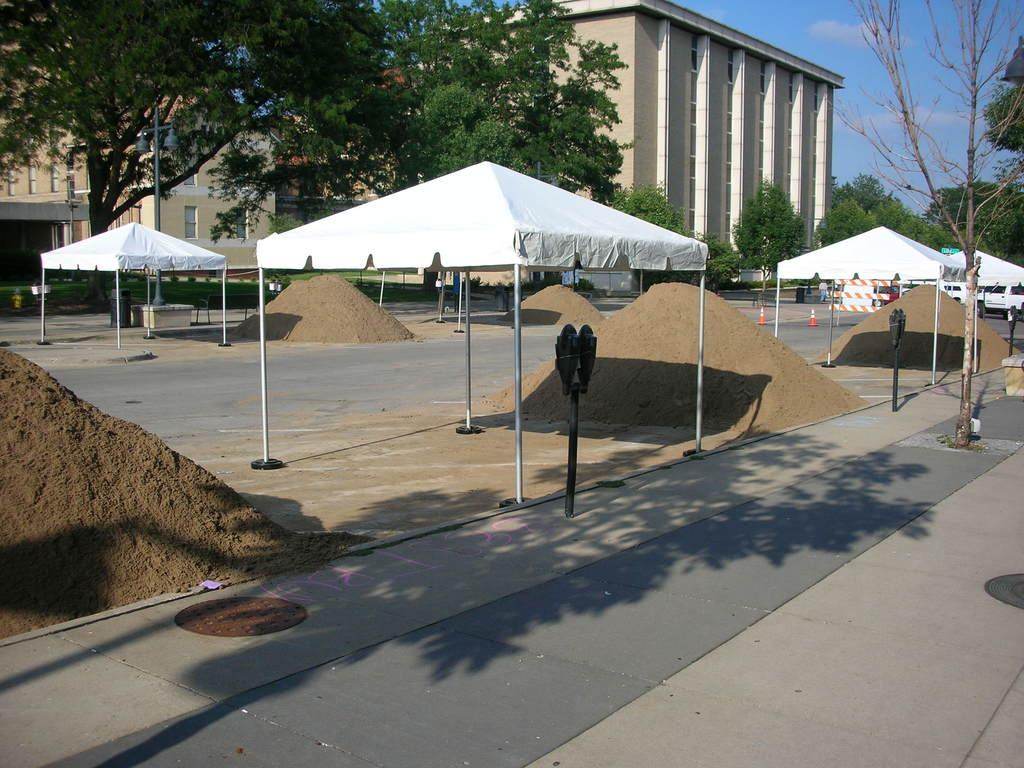What is the main subject in the center of the image? There are tents in the center of the image. What type of structures can be seen in the image? There are traffic poles and poles in the image. What type of transportation is present in the image? There are vehicles in the image. What type of terrain is visible in the image? There is sand in the image. What type of barrier is present in the image? There is a fence in the image. What type of pathway is present in the image? There is a road in the image. What can be seen in the background of the image? The sky, clouds, buildings, and trees can be seen in the background of the image. How many chickens are present in the image? There are no chickens present in the image. What type of pollution can be seen in the image? There is no pollution visible in the image. 